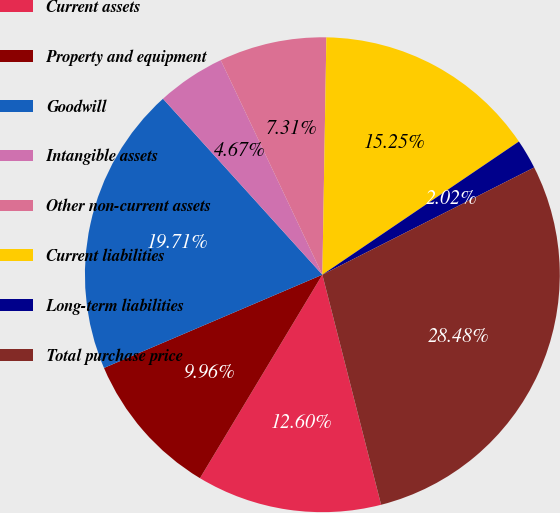Convert chart. <chart><loc_0><loc_0><loc_500><loc_500><pie_chart><fcel>Current assets<fcel>Property and equipment<fcel>Goodwill<fcel>Intangible assets<fcel>Other non-current assets<fcel>Current liabilities<fcel>Long-term liabilities<fcel>Total purchase price<nl><fcel>12.6%<fcel>9.96%<fcel>19.71%<fcel>4.67%<fcel>7.31%<fcel>15.25%<fcel>2.02%<fcel>28.48%<nl></chart> 